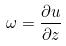Convert formula to latex. <formula><loc_0><loc_0><loc_500><loc_500>\omega = \frac { \partial u } { \partial z }</formula> 